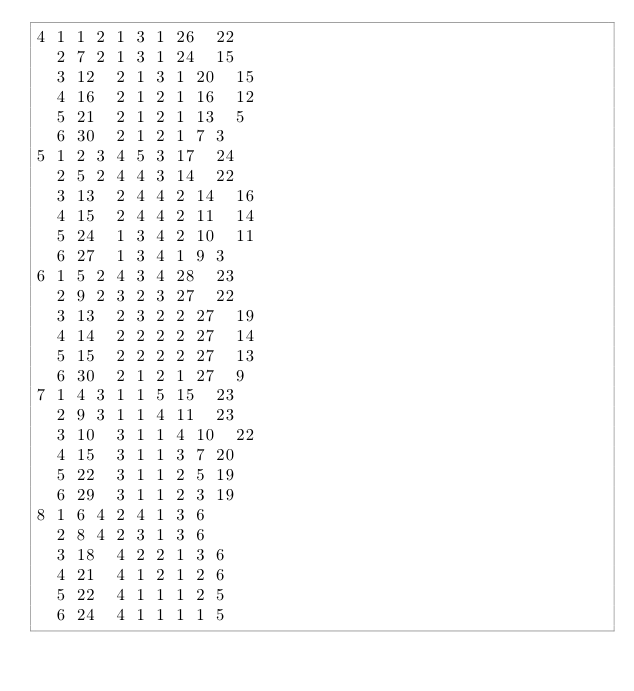Convert code to text. <code><loc_0><loc_0><loc_500><loc_500><_ObjectiveC_>4	1	1	2	1	3	1	26	22	
	2	7	2	1	3	1	24	15	
	3	12	2	1	3	1	20	15	
	4	16	2	1	2	1	16	12	
	5	21	2	1	2	1	13	5	
	6	30	2	1	2	1	7	3	
5	1	2	3	4	5	3	17	24	
	2	5	2	4	4	3	14	22	
	3	13	2	4	4	2	14	16	
	4	15	2	4	4	2	11	14	
	5	24	1	3	4	2	10	11	
	6	27	1	3	4	1	9	3	
6	1	5	2	4	3	4	28	23	
	2	9	2	3	2	3	27	22	
	3	13	2	3	2	2	27	19	
	4	14	2	2	2	2	27	14	
	5	15	2	2	2	2	27	13	
	6	30	2	1	2	1	27	9	
7	1	4	3	1	1	5	15	23	
	2	9	3	1	1	4	11	23	
	3	10	3	1	1	4	10	22	
	4	15	3	1	1	3	7	20	
	5	22	3	1	1	2	5	19	
	6	29	3	1	1	2	3	19	
8	1	6	4	2	4	1	3	6	
	2	8	4	2	3	1	3	6	
	3	18	4	2	2	1	3	6	
	4	21	4	1	2	1	2	6	
	5	22	4	1	1	1	2	5	
	6	24	4	1	1	1	1	5	</code> 